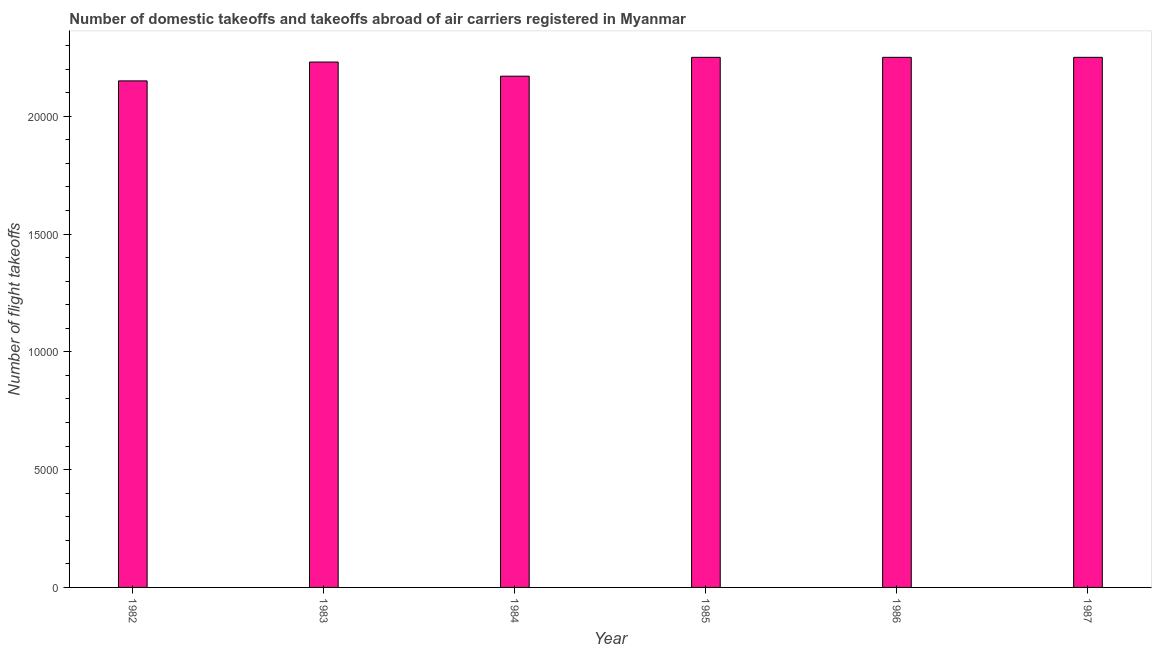Does the graph contain grids?
Offer a terse response. No. What is the title of the graph?
Offer a very short reply. Number of domestic takeoffs and takeoffs abroad of air carriers registered in Myanmar. What is the label or title of the Y-axis?
Make the answer very short. Number of flight takeoffs. What is the number of flight takeoffs in 1982?
Provide a succinct answer. 2.15e+04. Across all years, what is the maximum number of flight takeoffs?
Offer a terse response. 2.25e+04. Across all years, what is the minimum number of flight takeoffs?
Provide a succinct answer. 2.15e+04. In which year was the number of flight takeoffs minimum?
Offer a very short reply. 1982. What is the sum of the number of flight takeoffs?
Keep it short and to the point. 1.33e+05. What is the difference between the number of flight takeoffs in 1984 and 1985?
Give a very brief answer. -800. What is the average number of flight takeoffs per year?
Make the answer very short. 2.22e+04. What is the median number of flight takeoffs?
Your answer should be very brief. 2.24e+04. Do a majority of the years between 1985 and 1982 (inclusive) have number of flight takeoffs greater than 4000 ?
Give a very brief answer. Yes. Is the number of flight takeoffs in 1985 less than that in 1987?
Provide a succinct answer. No. What is the difference between the highest and the second highest number of flight takeoffs?
Offer a very short reply. 0. What is the difference between the highest and the lowest number of flight takeoffs?
Keep it short and to the point. 1000. How many bars are there?
Your answer should be compact. 6. Are all the bars in the graph horizontal?
Your answer should be compact. No. How many years are there in the graph?
Give a very brief answer. 6. Are the values on the major ticks of Y-axis written in scientific E-notation?
Keep it short and to the point. No. What is the Number of flight takeoffs of 1982?
Make the answer very short. 2.15e+04. What is the Number of flight takeoffs in 1983?
Provide a short and direct response. 2.23e+04. What is the Number of flight takeoffs of 1984?
Offer a terse response. 2.17e+04. What is the Number of flight takeoffs in 1985?
Your answer should be very brief. 2.25e+04. What is the Number of flight takeoffs in 1986?
Your answer should be compact. 2.25e+04. What is the Number of flight takeoffs in 1987?
Your response must be concise. 2.25e+04. What is the difference between the Number of flight takeoffs in 1982 and 1983?
Offer a terse response. -800. What is the difference between the Number of flight takeoffs in 1982 and 1984?
Give a very brief answer. -200. What is the difference between the Number of flight takeoffs in 1982 and 1985?
Give a very brief answer. -1000. What is the difference between the Number of flight takeoffs in 1982 and 1986?
Your answer should be compact. -1000. What is the difference between the Number of flight takeoffs in 1982 and 1987?
Give a very brief answer. -1000. What is the difference between the Number of flight takeoffs in 1983 and 1984?
Make the answer very short. 600. What is the difference between the Number of flight takeoffs in 1983 and 1985?
Offer a very short reply. -200. What is the difference between the Number of flight takeoffs in 1983 and 1986?
Offer a terse response. -200. What is the difference between the Number of flight takeoffs in 1983 and 1987?
Offer a very short reply. -200. What is the difference between the Number of flight takeoffs in 1984 and 1985?
Your response must be concise. -800. What is the difference between the Number of flight takeoffs in 1984 and 1986?
Offer a very short reply. -800. What is the difference between the Number of flight takeoffs in 1984 and 1987?
Ensure brevity in your answer.  -800. What is the difference between the Number of flight takeoffs in 1985 and 1986?
Your answer should be very brief. 0. What is the difference between the Number of flight takeoffs in 1985 and 1987?
Your response must be concise. 0. What is the difference between the Number of flight takeoffs in 1986 and 1987?
Your answer should be compact. 0. What is the ratio of the Number of flight takeoffs in 1982 to that in 1984?
Offer a terse response. 0.99. What is the ratio of the Number of flight takeoffs in 1982 to that in 1985?
Your response must be concise. 0.96. What is the ratio of the Number of flight takeoffs in 1982 to that in 1986?
Your answer should be very brief. 0.96. What is the ratio of the Number of flight takeoffs in 1982 to that in 1987?
Ensure brevity in your answer.  0.96. What is the ratio of the Number of flight takeoffs in 1983 to that in 1984?
Offer a terse response. 1.03. What is the ratio of the Number of flight takeoffs in 1984 to that in 1987?
Give a very brief answer. 0.96. What is the ratio of the Number of flight takeoffs in 1985 to that in 1987?
Provide a short and direct response. 1. What is the ratio of the Number of flight takeoffs in 1986 to that in 1987?
Provide a short and direct response. 1. 